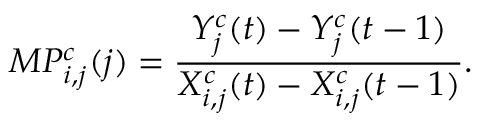Convert formula to latex. <formula><loc_0><loc_0><loc_500><loc_500>M P _ { i , j } ^ { c } ( j ) = \frac { Y _ { j } ^ { c } ( t ) - Y _ { j } ^ { c } ( t - 1 ) } { X _ { i , j } ^ { c } ( t ) - X _ { i , j } ^ { c } ( t - 1 ) } .</formula> 